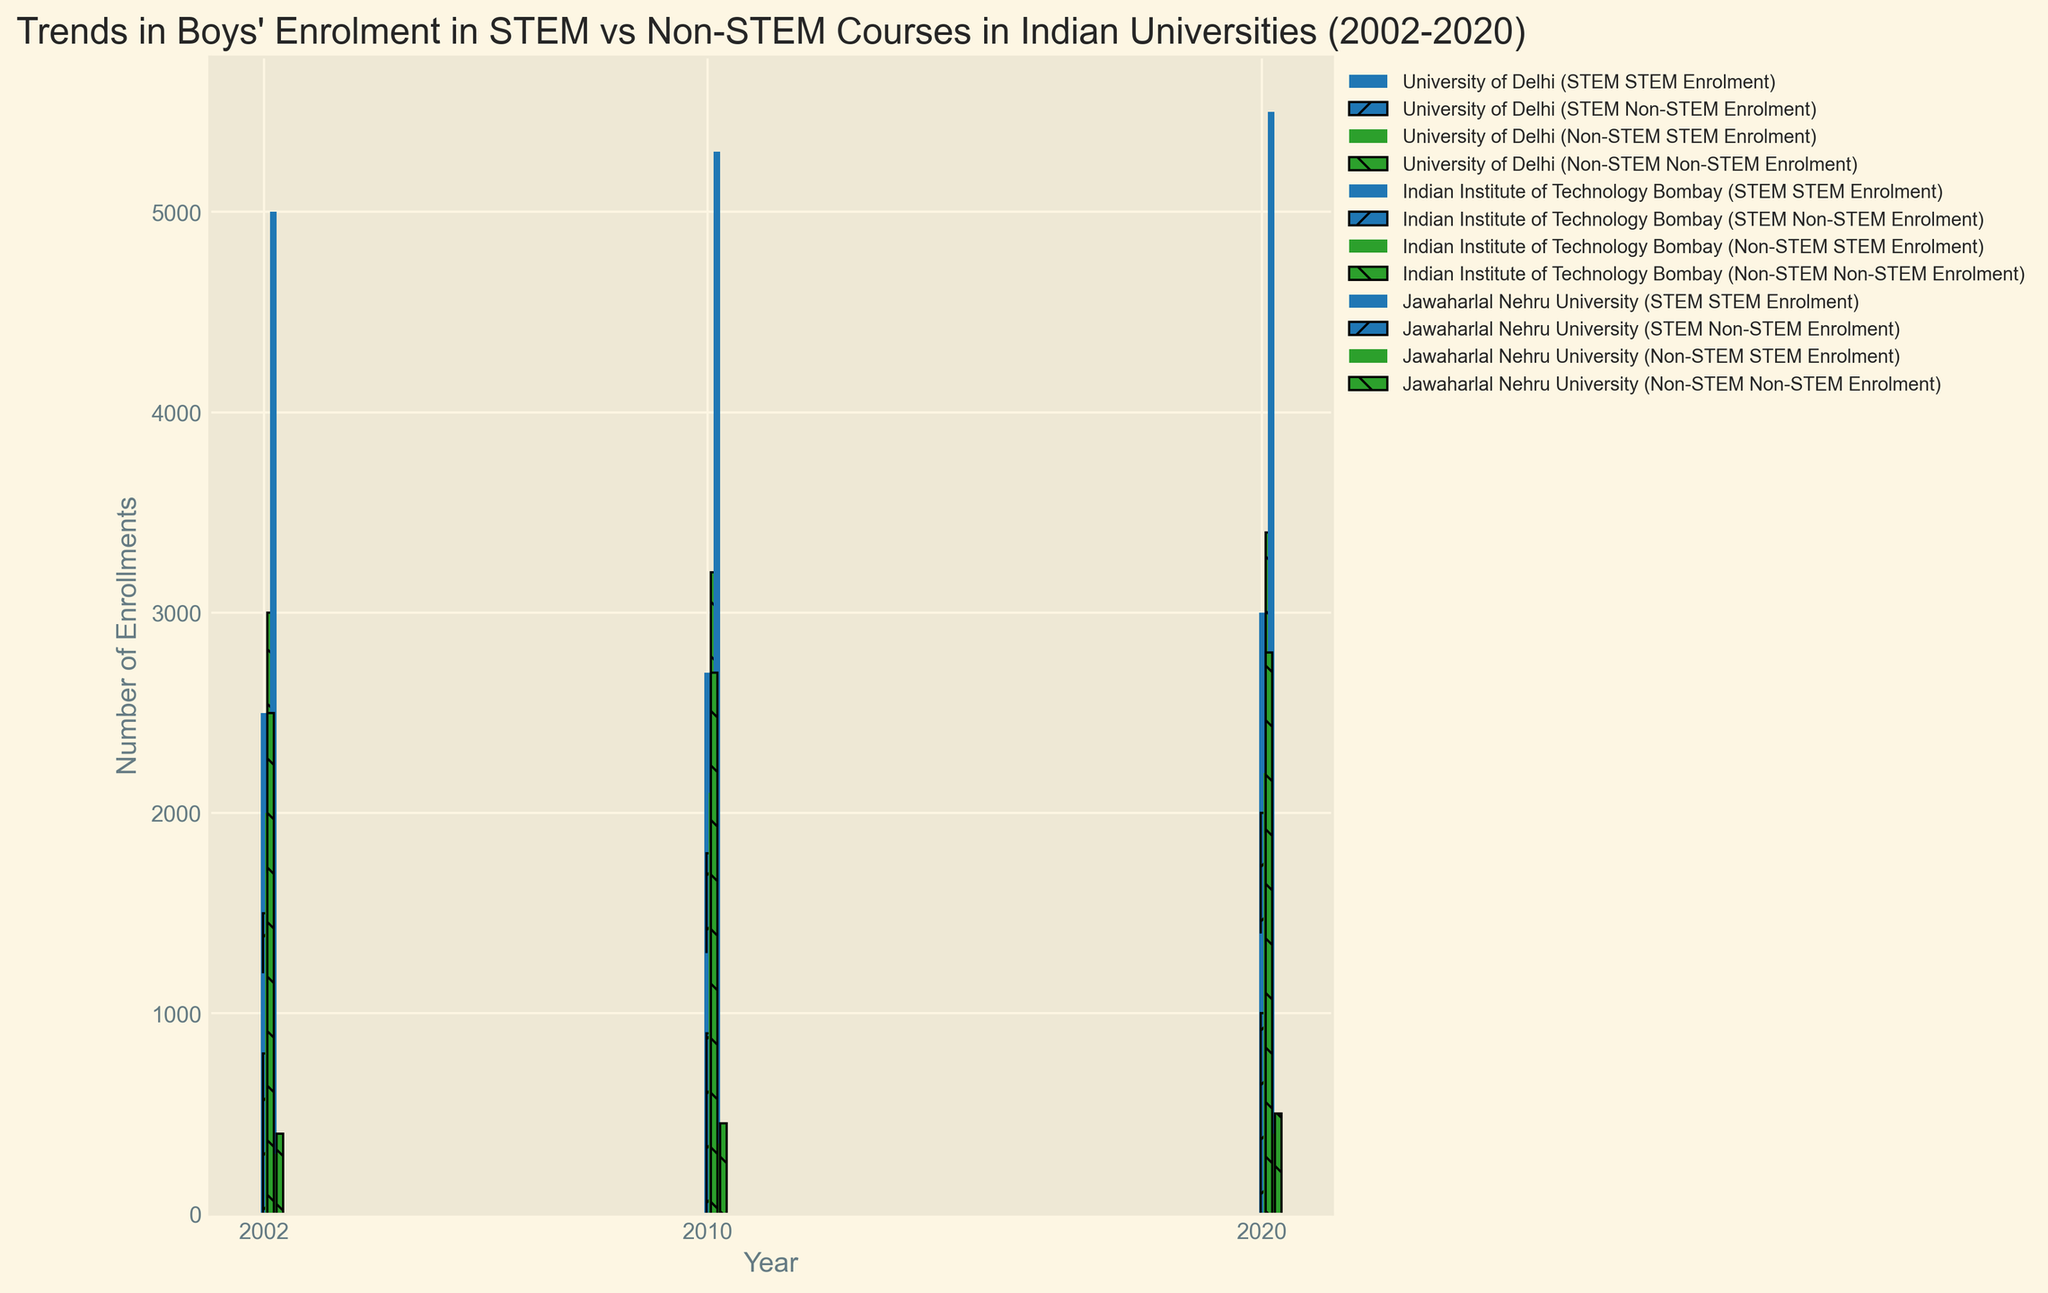What is the trend in STEM enrolment at the University of Delhi from 2002 to 2020? To determine the trend in STEM enrolment at the University of Delhi, observe the heights of the bars labeled "University of Delhi (STEM Enrolment)" for the years 2002, 2010, and 2020. There is a steady increase in the number of STEM enrolments from 2500 in 2002, 2700 in 2010, to 3000 in 2020.
Answer: Increasing Which university had the highest non-STEM enrolment in 2020? To identify the university with the highest non-STEM enrolment in 2020, compare the heights of the bars for non-STEM categories in 2020. The University of Delhi had the highest non-STEM enrolment with 3400 students.
Answer: University of Delhi How has the STEM enrolment in Jawaharlal Nehru University changed from 2002 to 2020? Look at the bars labeled "Jawaharlal Nehru University (STEM Enrolment)" for the years 2002, 2010, and 2020. The STEM enrolment has gradually increased from 1200 in 2002 to 1300 in 2010 and 1400 in 2020.
Answer: Increased Compare the ratio of STEM to non-STEM enrolment in IIT Bombay in 2020. Find the bars for IIT Bombay in 2020. STEM enrolment is 5500 and non-STEM enrolment is 500. The ratio is 5500/500, which simplifies to 11:1.
Answer: 11:1 What is the trend in non-STEM enrolment at Jawaharlal Nehru University over the years? Observe the bars labeled "Jawaharlal Nehru University (Non-STEM Enrolment)" for 2002, 2010, and 2020. The enrolment figures are 2500, 2700, and 2800 respectively, indicating a gradual increase over the years.
Answer: Increasing Between 2002 and 2020, which university saw the largest increase in STEM enrolment? Compare the differences in STEM enrolment for each university between 2002 and 2020. University of Delhi increased by 500 students (3000-2500), IIT Bombay increased by 500 students (5500-5000), and Jawaharlal Nehru University increased by 200 students (1400-1200). Both the University of Delhi and IIT Bombay saw the largest increase of 500 students.
Answer: University of Delhi and IIT Bombay Which year had the lowest non-STEM enrolment across all universities? Examine the heights of the non-STEM enrolment bars for all universities across the years. 2002 has the lowest non-STEM enrolment, with enrolments ranging from 400 to 3000 students in individual universities.
Answer: 2002 What is the difference in enrolment between STEM and non-STEM categories at Jawaharlal Nehru University in 2010? Find the bars for Jawaharlal Nehru University in 2010. STEM enrolment is 1300 and non-STEM enrolment is 2700. The difference is 2700 - 1300 = 1400.
Answer: 1400 For which year does the University of Delhi have the highest disparity between STEM and non-STEM enrolment? Compare the differences between STEM and non-STEM enrolments for the University of Delhi in each year. 2020 has a disparity of 1400 (3400 - 2000), which is the highest compared to 500 in both 2002 (3000 - 2500) and 2010 (3200 - 2700).
Answer: 2020 